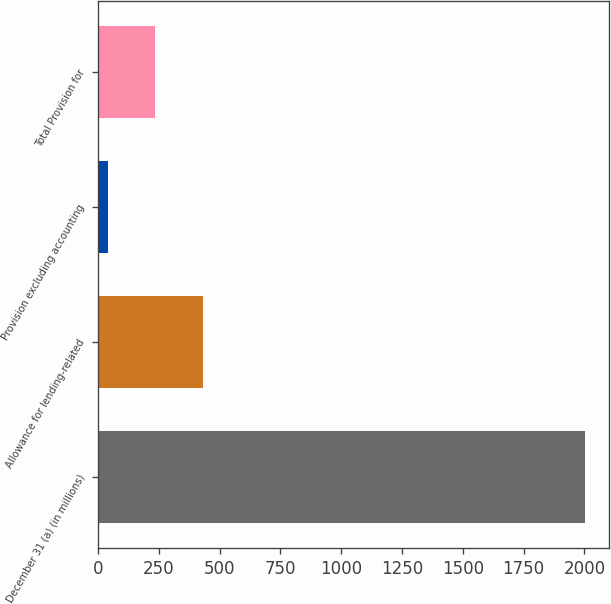Convert chart to OTSL. <chart><loc_0><loc_0><loc_500><loc_500><bar_chart><fcel>December 31 (a) (in millions)<fcel>Allowance for lending-related<fcel>Provision excluding accounting<fcel>Total Provision for<nl><fcel>2003<fcel>431.8<fcel>39<fcel>235.4<nl></chart> 